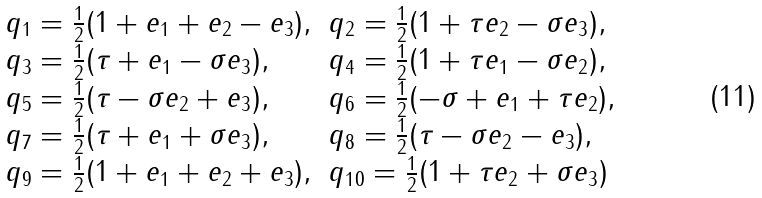Convert formula to latex. <formula><loc_0><loc_0><loc_500><loc_500>\begin{array} { l l } q _ { 1 } = \frac { 1 } { 2 } ( 1 + e _ { 1 } + e _ { 2 } - e _ { 3 } ) , & q _ { 2 } = \frac { 1 } { 2 } ( 1 + \tau e _ { 2 } - \sigma e _ { 3 } ) , \\ q _ { 3 } = \frac { 1 } { 2 } ( \tau + e _ { 1 } - \sigma e _ { 3 } ) , & q _ { 4 } = \frac { 1 } { 2 } ( 1 + \tau e _ { 1 } - \sigma e _ { 2 } ) , \\ q _ { 5 } = \frac { 1 } { 2 } ( \tau - \sigma e _ { 2 } + e _ { 3 } ) , & q _ { 6 } = \frac { 1 } { 2 } ( - \sigma + e _ { 1 } + \tau e _ { 2 } ) , \\ q _ { 7 } = \frac { 1 } { 2 } ( \tau + e _ { 1 } + \sigma e _ { 3 } ) , & q _ { 8 } = \frac { 1 } { 2 } ( \tau - \sigma e _ { 2 } - e _ { 3 } ) , \\ q _ { 9 } = \frac { 1 } { 2 } ( 1 + e _ { 1 } + e _ { 2 } + e _ { 3 } ) , & q _ { 1 0 } = \frac { 1 } { 2 } ( 1 + \tau e _ { 2 } + \sigma e _ { 3 } ) \end{array}</formula> 